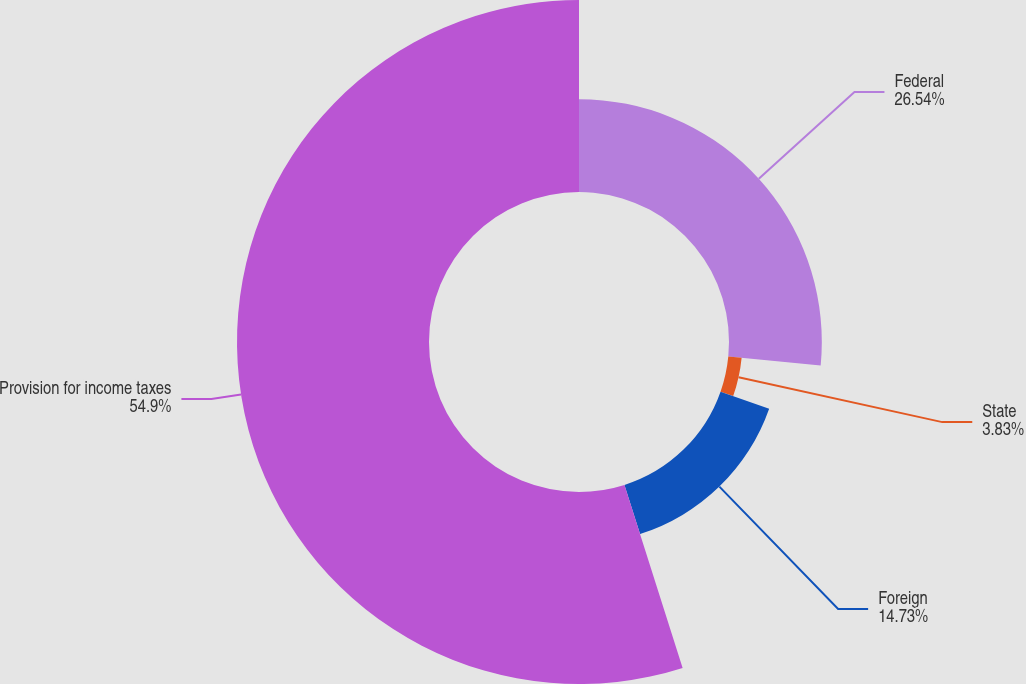Convert chart to OTSL. <chart><loc_0><loc_0><loc_500><loc_500><pie_chart><fcel>Federal<fcel>State<fcel>Foreign<fcel>Provision for income taxes<nl><fcel>26.54%<fcel>3.83%<fcel>14.73%<fcel>54.9%<nl></chart> 